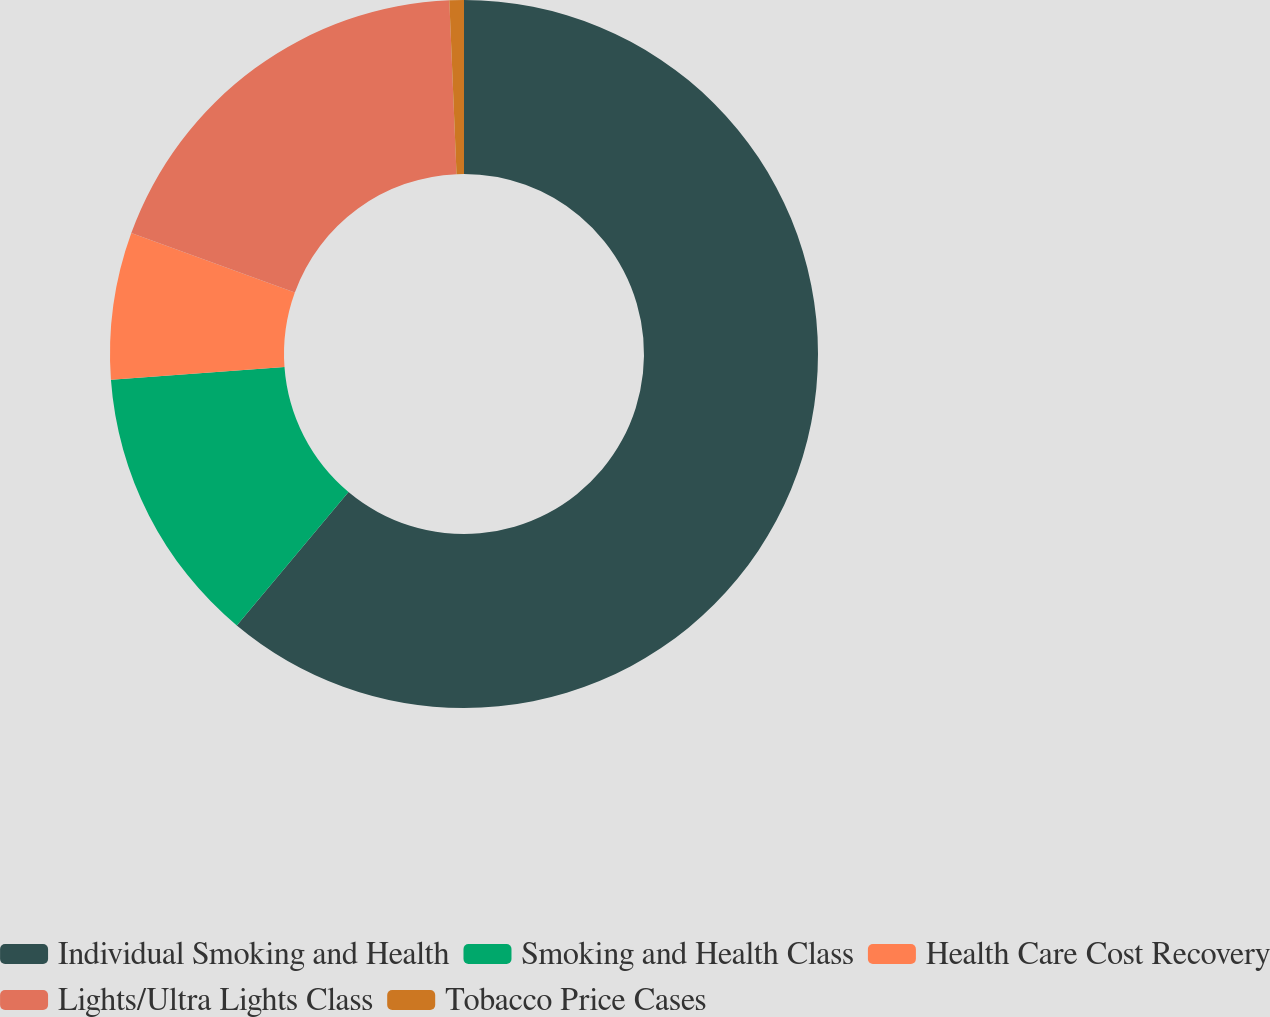Convert chart to OTSL. <chart><loc_0><loc_0><loc_500><loc_500><pie_chart><fcel>Individual Smoking and Health<fcel>Smoking and Health Class<fcel>Health Care Cost Recovery<fcel>Lights/Ultra Lights Class<fcel>Tobacco Price Cases<nl><fcel>61.09%<fcel>12.75%<fcel>6.71%<fcel>18.79%<fcel>0.66%<nl></chart> 